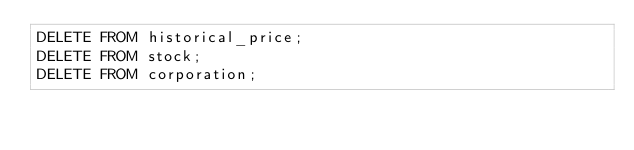Convert code to text. <code><loc_0><loc_0><loc_500><loc_500><_SQL_>DELETE FROM historical_price;
DELETE FROM stock;
DELETE FROM corporation;</code> 